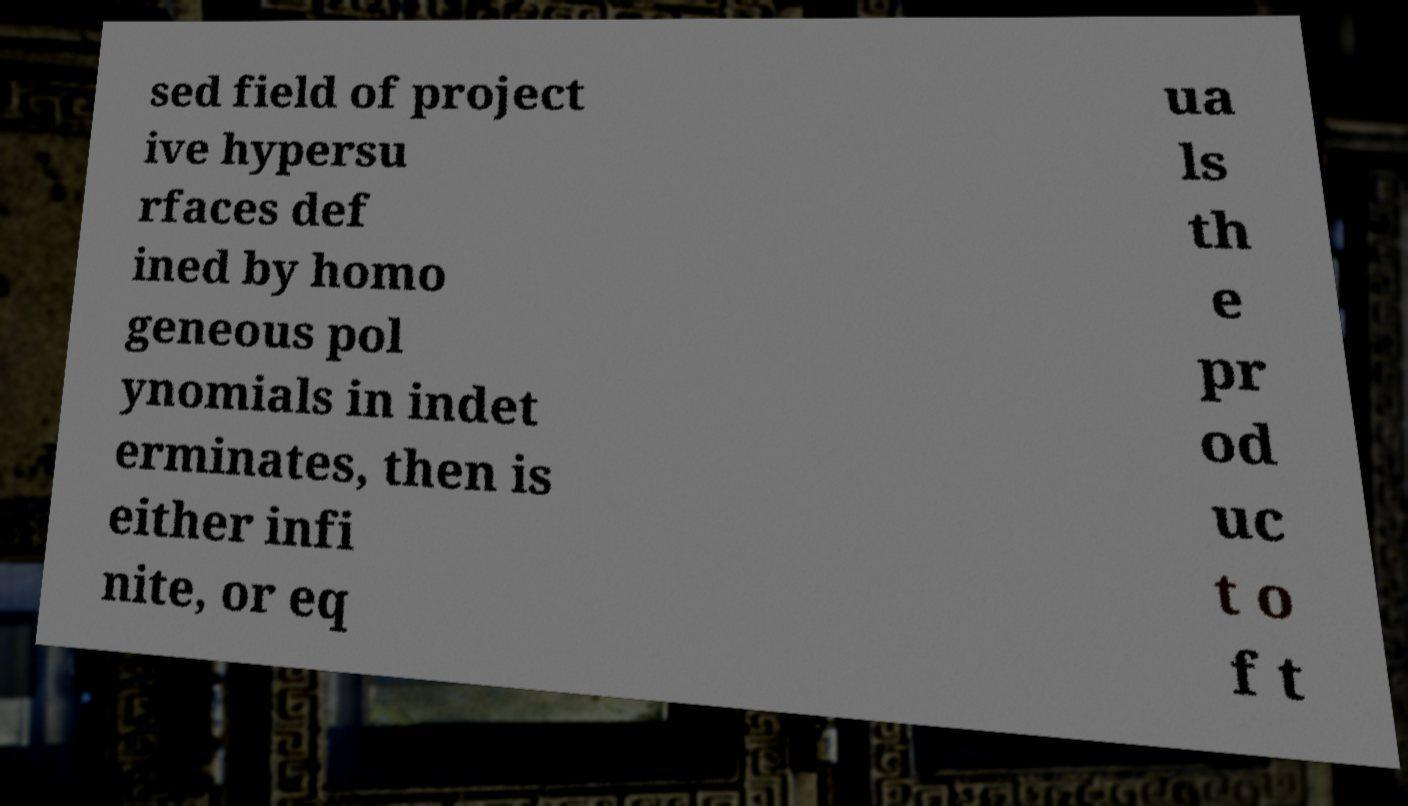There's text embedded in this image that I need extracted. Can you transcribe it verbatim? sed field of project ive hypersu rfaces def ined by homo geneous pol ynomials in indet erminates, then is either infi nite, or eq ua ls th e pr od uc t o f t 